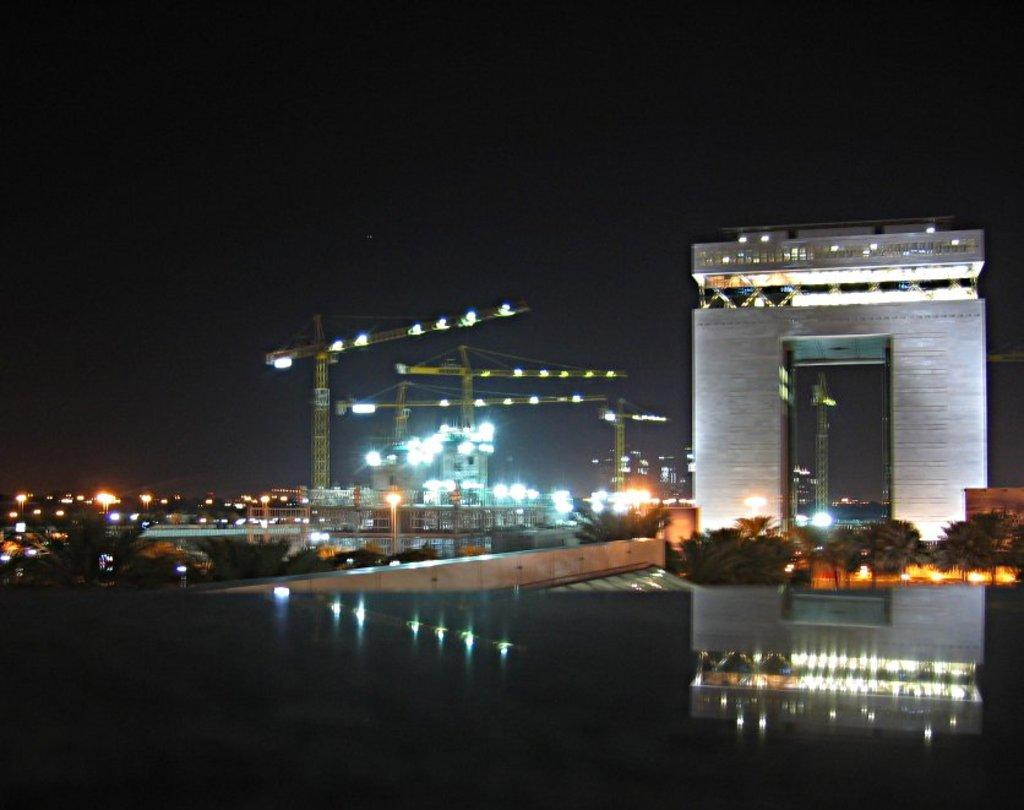What type of living organisms can be seen in the image? Plants are visible in the image. What architectural feature is present in the image? There is an arch in the image. What can be seen on the left side of the image? Lights and a rotator are visible on the left side of the image, along with trees. What is visible at the top of the image? The sky is visible at the top of the image. What is the color of the bottom part of the image? The bottom of the image appears to be black in color. What type of shock can be seen in the image? There is no shock present in the image. Is there a lake visible in the image? No, there is no lake present in the image. 